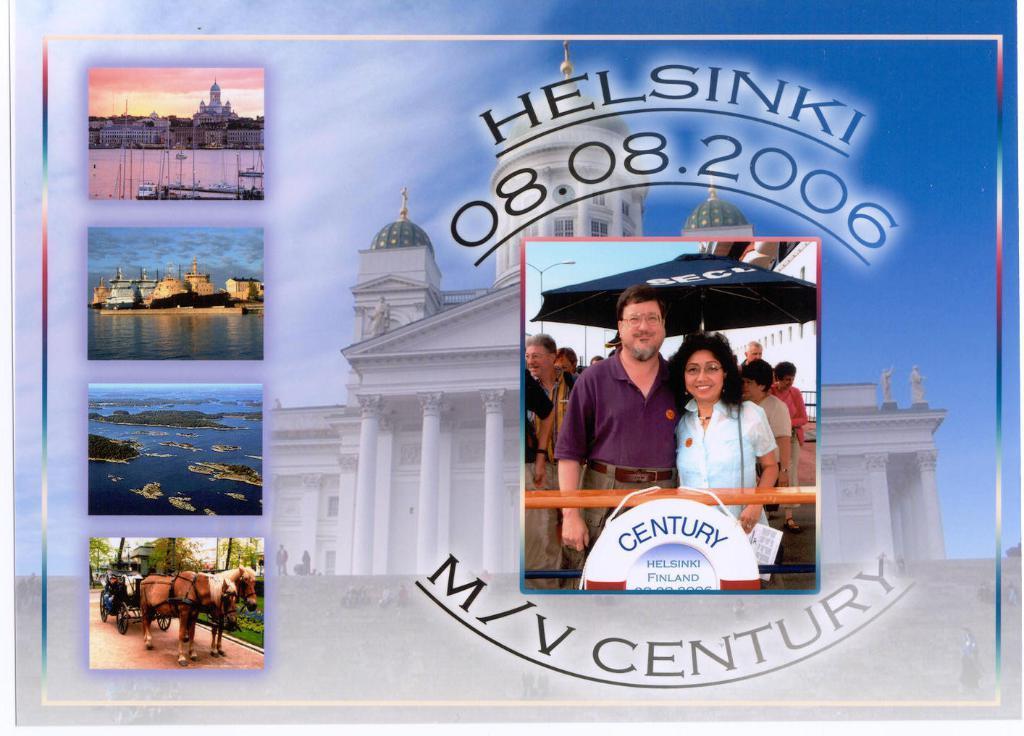Please provide a concise description of this image. In this picture I can see few people on the right side, on the left side there is a photo collage. In the background there is a building at the top there is the sky, it is an edited image. 